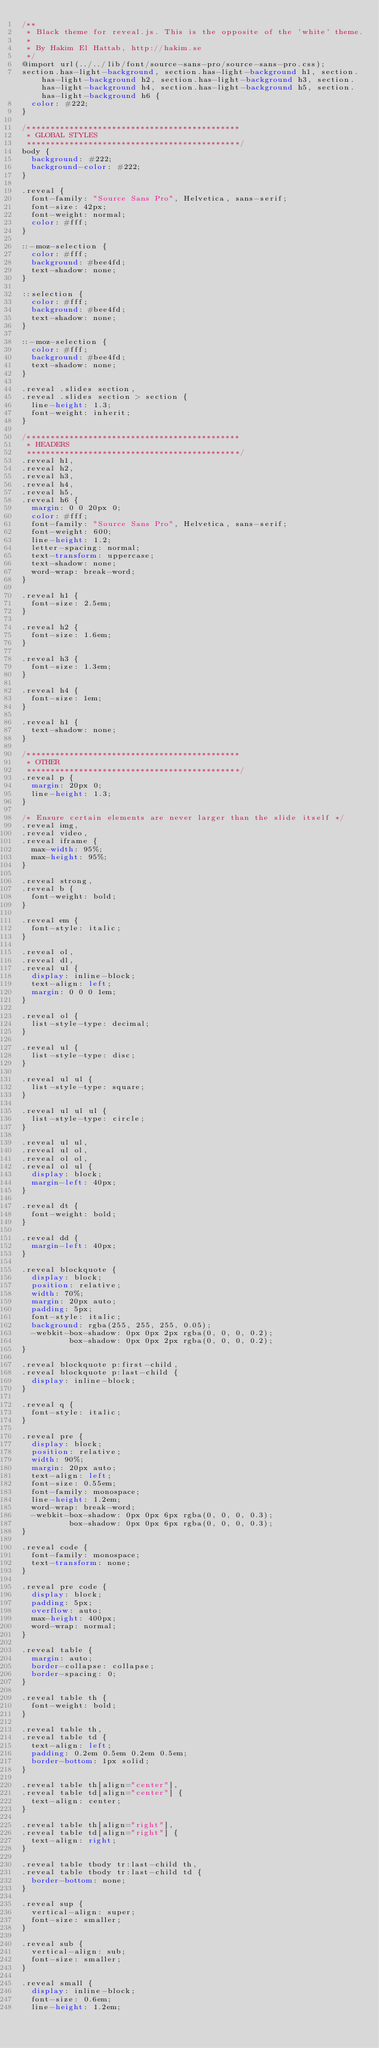<code> <loc_0><loc_0><loc_500><loc_500><_CSS_>/**
 * Black theme for reveal.js. This is the opposite of the 'white' theme.
 *
 * By Hakim El Hattab, http://hakim.se
 */
@import url(../../lib/font/source-sans-pro/source-sans-pro.css);
section.has-light-background, section.has-light-background h1, section.has-light-background h2, section.has-light-background h3, section.has-light-background h4, section.has-light-background h5, section.has-light-background h6 {
  color: #222;
}

/*********************************************
 * GLOBAL STYLES
 *********************************************/
body {
  background: #222;
  background-color: #222;
}

.reveal {
  font-family: "Source Sans Pro", Helvetica, sans-serif;
  font-size: 42px;
  font-weight: normal;
  color: #fff;
}

::-moz-selection {
  color: #fff;
  background: #bee4fd;
  text-shadow: none;
}

::selection {
  color: #fff;
  background: #bee4fd;
  text-shadow: none;
}

::-moz-selection {
  color: #fff;
  background: #bee4fd;
  text-shadow: none;
}

.reveal .slides section,
.reveal .slides section > section {
  line-height: 1.3;
  font-weight: inherit;
}

/*********************************************
 * HEADERS
 *********************************************/
.reveal h1,
.reveal h2,
.reveal h3,
.reveal h4,
.reveal h5,
.reveal h6 {
  margin: 0 0 20px 0;
  color: #fff;
  font-family: "Source Sans Pro", Helvetica, sans-serif;
  font-weight: 600;
  line-height: 1.2;
  letter-spacing: normal;
  text-transform: uppercase;
  text-shadow: none;
  word-wrap: break-word;
}

.reveal h1 {
  font-size: 2.5em;
}

.reveal h2 {
  font-size: 1.6em;
}

.reveal h3 {
  font-size: 1.3em;
}

.reveal h4 {
  font-size: 1em;
}

.reveal h1 {
  text-shadow: none;
}

/*********************************************
 * OTHER
 *********************************************/
.reveal p {
  margin: 20px 0;
  line-height: 1.3;
}

/* Ensure certain elements are never larger than the slide itself */
.reveal img,
.reveal video,
.reveal iframe {
  max-width: 95%;
  max-height: 95%;
}

.reveal strong,
.reveal b {
  font-weight: bold;
}

.reveal em {
  font-style: italic;
}

.reveal ol,
.reveal dl,
.reveal ul {
  display: inline-block;
  text-align: left;
  margin: 0 0 0 1em;
}

.reveal ol {
  list-style-type: decimal;
}

.reveal ul {
  list-style-type: disc;
}

.reveal ul ul {
  list-style-type: square;
}

.reveal ul ul ul {
  list-style-type: circle;
}

.reveal ul ul,
.reveal ul ol,
.reveal ol ol,
.reveal ol ul {
  display: block;
  margin-left: 40px;
}

.reveal dt {
  font-weight: bold;
}

.reveal dd {
  margin-left: 40px;
}

.reveal blockquote {
  display: block;
  position: relative;
  width: 70%;
  margin: 20px auto;
  padding: 5px;
  font-style: italic;
  background: rgba(255, 255, 255, 0.05);
  -webkit-box-shadow: 0px 0px 2px rgba(0, 0, 0, 0.2);
          box-shadow: 0px 0px 2px rgba(0, 0, 0, 0.2);
}

.reveal blockquote p:first-child,
.reveal blockquote p:last-child {
  display: inline-block;
}

.reveal q {
  font-style: italic;
}

.reveal pre {
  display: block;
  position: relative;
  width: 90%;
  margin: 20px auto;
  text-align: left;
  font-size: 0.55em;
  font-family: monospace;
  line-height: 1.2em;
  word-wrap: break-word;
  -webkit-box-shadow: 0px 0px 6px rgba(0, 0, 0, 0.3);
          box-shadow: 0px 0px 6px rgba(0, 0, 0, 0.3);
}

.reveal code {
  font-family: monospace;
  text-transform: none;
}

.reveal pre code {
  display: block;
  padding: 5px;
  overflow: auto;
  max-height: 400px;
  word-wrap: normal;
}

.reveal table {
  margin: auto;
  border-collapse: collapse;
  border-spacing: 0;
}

.reveal table th {
  font-weight: bold;
}

.reveal table th,
.reveal table td {
  text-align: left;
  padding: 0.2em 0.5em 0.2em 0.5em;
  border-bottom: 1px solid;
}

.reveal table th[align="center"],
.reveal table td[align="center"] {
  text-align: center;
}

.reveal table th[align="right"],
.reveal table td[align="right"] {
  text-align: right;
}

.reveal table tbody tr:last-child th,
.reveal table tbody tr:last-child td {
  border-bottom: none;
}

.reveal sup {
  vertical-align: super;
  font-size: smaller;
}

.reveal sub {
  vertical-align: sub;
  font-size: smaller;
}

.reveal small {
  display: inline-block;
  font-size: 0.6em;
  line-height: 1.2em;</code> 